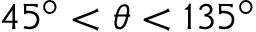<formula> <loc_0><loc_0><loc_500><loc_500>4 5 ^ { \circ } < \theta < 1 3 5 ^ { \circ }</formula> 